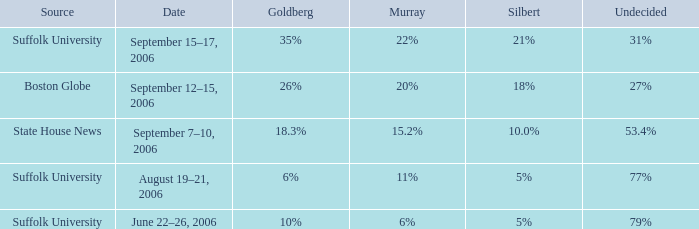0%? September 7–10, 2006. 